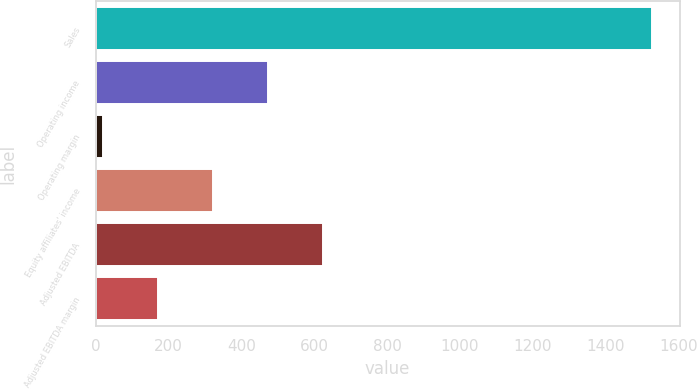<chart> <loc_0><loc_0><loc_500><loc_500><bar_chart><fcel>Sales<fcel>Operating income<fcel>Operating margin<fcel>Equity affiliates' income<fcel>Adjusted EBITDA<fcel>Adjusted EBITDA margin<nl><fcel>1527<fcel>472.31<fcel>20.3<fcel>321.64<fcel>622.98<fcel>170.97<nl></chart> 